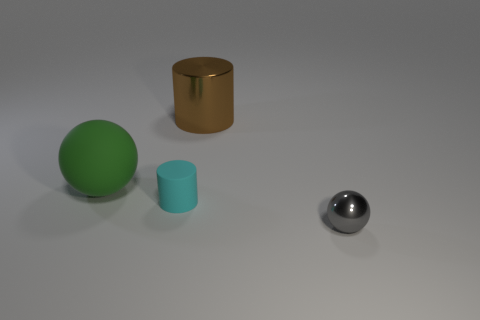Is there any other thing that is the same shape as the large green object? Yes, there is a smaller object that shares the same spherical shape as the large green object. 